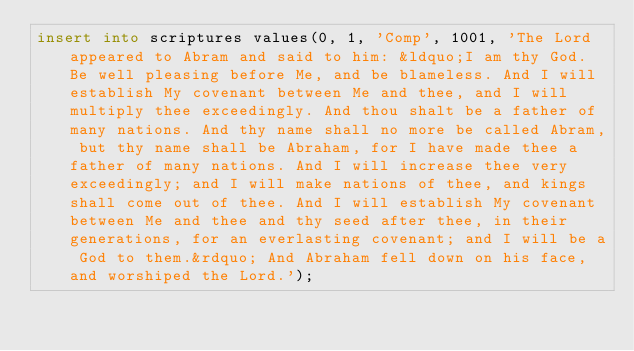<code> <loc_0><loc_0><loc_500><loc_500><_SQL_>insert into scriptures values(0, 1, 'Comp', 1001, 'The Lord appeared to Abram and said to him: &ldquo;I am thy God. Be well pleasing before Me, and be blameless. And I will establish My covenant between Me and thee, and I will multiply thee exceedingly. And thou shalt be a father of many nations. And thy name shall no more be called Abram, but thy name shall be Abraham, for I have made thee a father of many nations. And I will increase thee very exceedingly; and I will make nations of thee, and kings shall come out of thee. And I will establish My covenant between Me and thee and thy seed after thee, in their generations, for an everlasting covenant; and I will be a God to them.&rdquo; And Abraham fell down on his face, and worshiped the Lord.');</code> 